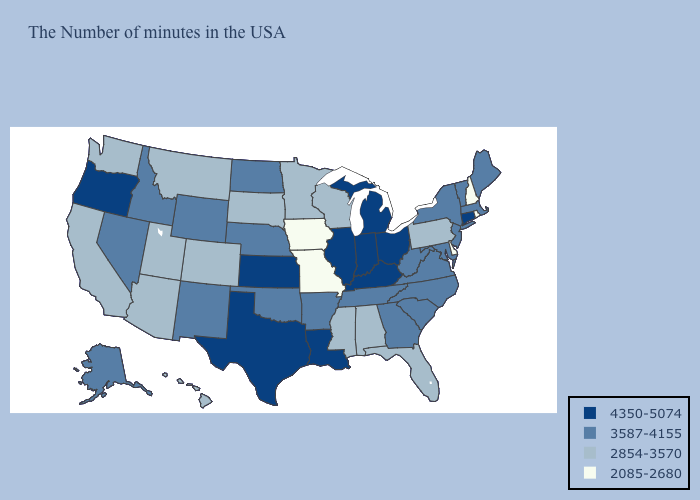Does the map have missing data?
Be succinct. No. Among the states that border Tennessee , which have the highest value?
Write a very short answer. Kentucky. Does Rhode Island have the lowest value in the USA?
Quick response, please. Yes. Does North Dakota have a lower value than Tennessee?
Give a very brief answer. No. Does Louisiana have a higher value than Maine?
Keep it brief. Yes. How many symbols are there in the legend?
Answer briefly. 4. What is the lowest value in the USA?
Write a very short answer. 2085-2680. How many symbols are there in the legend?
Give a very brief answer. 4. Does the first symbol in the legend represent the smallest category?
Keep it brief. No. Which states have the lowest value in the USA?
Answer briefly. Rhode Island, New Hampshire, Delaware, Missouri, Iowa. Does Oregon have the same value as Connecticut?
Write a very short answer. Yes. What is the value of Washington?
Be succinct. 2854-3570. What is the value of Idaho?
Write a very short answer. 3587-4155. Does Missouri have the lowest value in the MidWest?
Give a very brief answer. Yes. Does Arkansas have a lower value than Kentucky?
Concise answer only. Yes. 